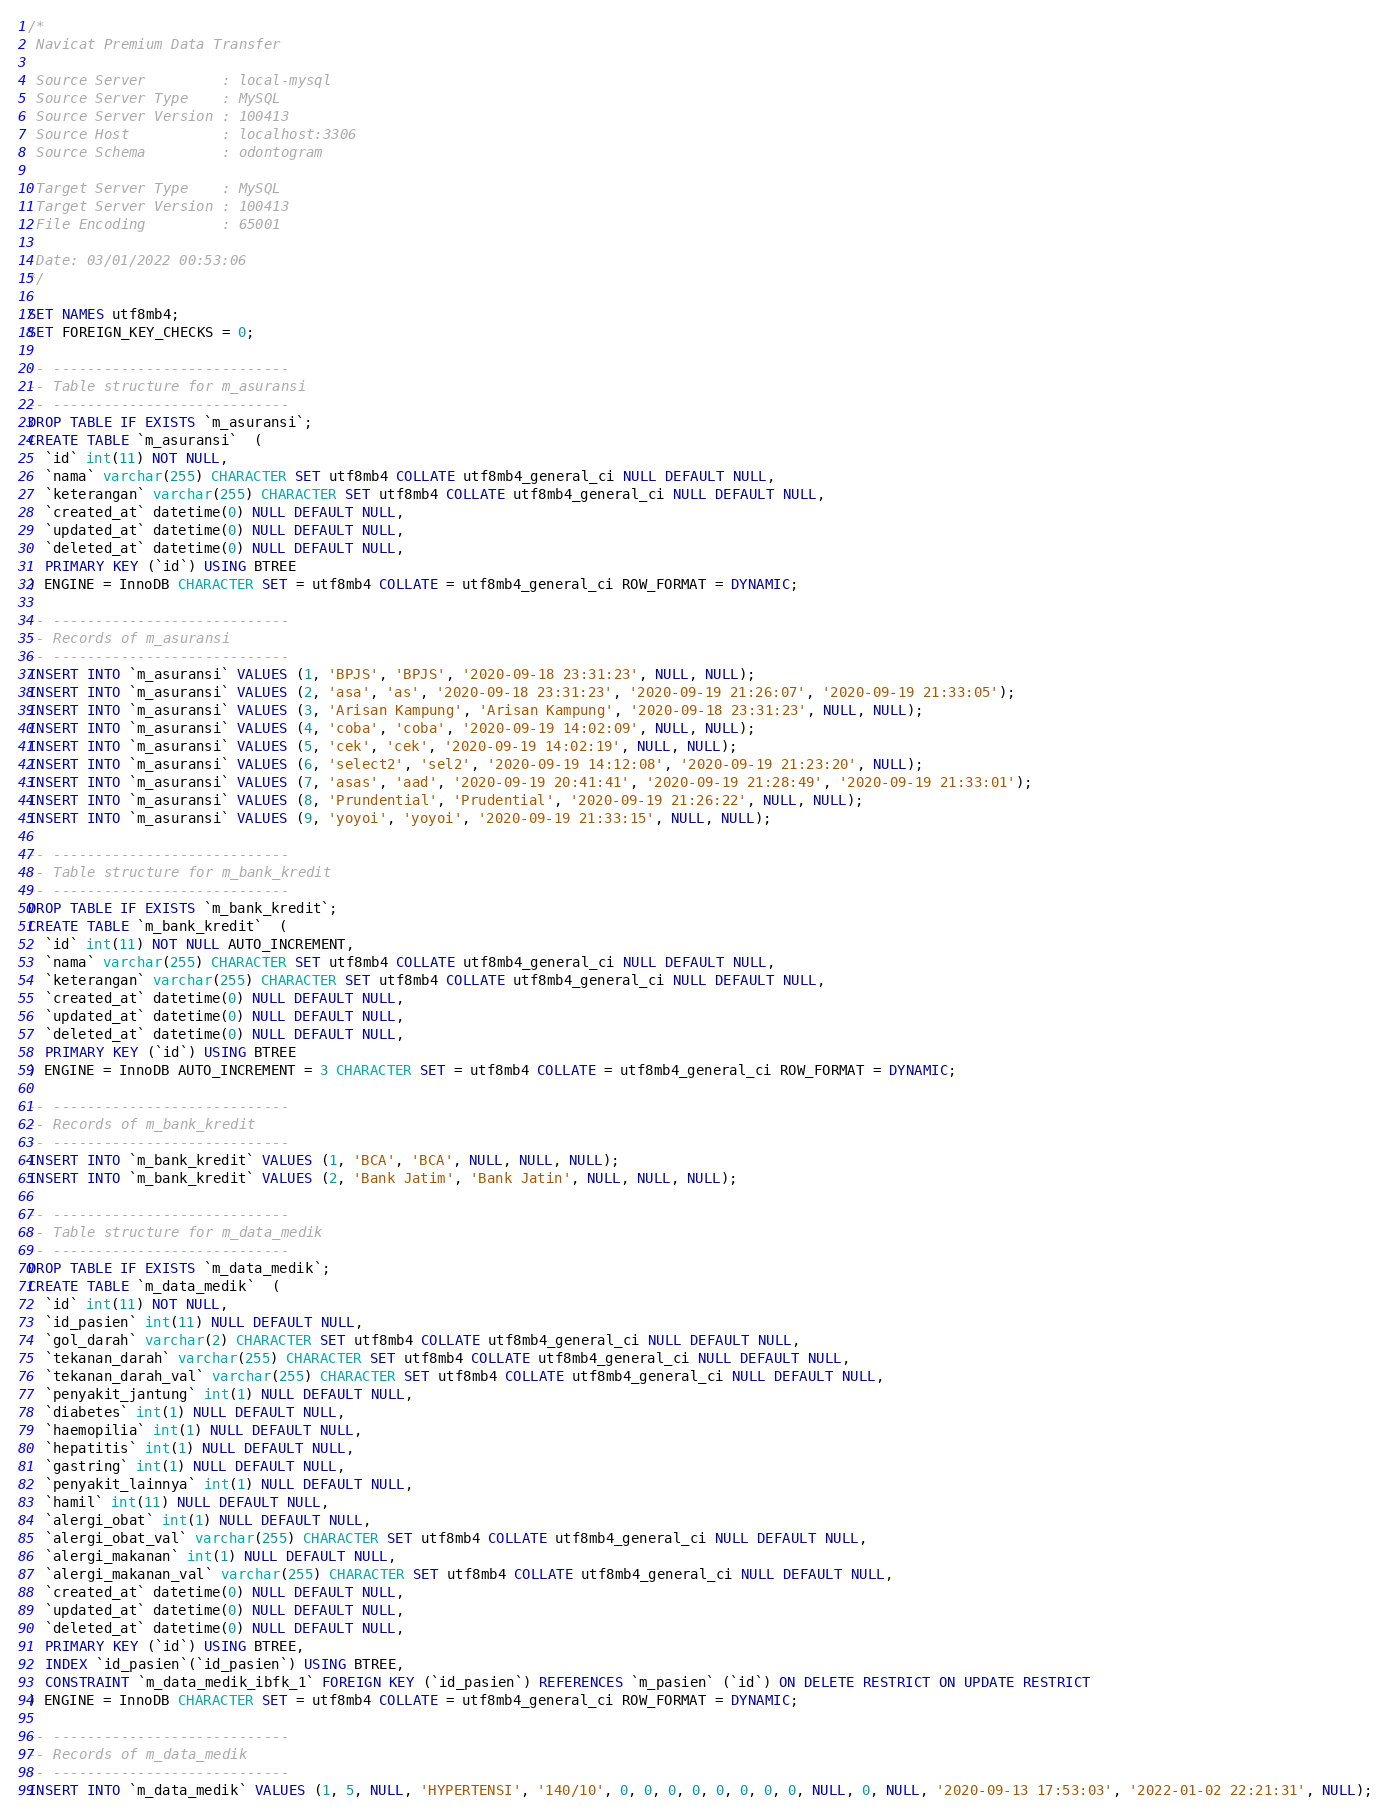Convert code to text. <code><loc_0><loc_0><loc_500><loc_500><_SQL_>/*
 Navicat Premium Data Transfer

 Source Server         : local-mysql
 Source Server Type    : MySQL
 Source Server Version : 100413
 Source Host           : localhost:3306
 Source Schema         : odontogram

 Target Server Type    : MySQL
 Target Server Version : 100413
 File Encoding         : 65001

 Date: 03/01/2022 00:53:06
*/

SET NAMES utf8mb4;
SET FOREIGN_KEY_CHECKS = 0;

-- ----------------------------
-- Table structure for m_asuransi
-- ----------------------------
DROP TABLE IF EXISTS `m_asuransi`;
CREATE TABLE `m_asuransi`  (
  `id` int(11) NOT NULL,
  `nama` varchar(255) CHARACTER SET utf8mb4 COLLATE utf8mb4_general_ci NULL DEFAULT NULL,
  `keterangan` varchar(255) CHARACTER SET utf8mb4 COLLATE utf8mb4_general_ci NULL DEFAULT NULL,
  `created_at` datetime(0) NULL DEFAULT NULL,
  `updated_at` datetime(0) NULL DEFAULT NULL,
  `deleted_at` datetime(0) NULL DEFAULT NULL,
  PRIMARY KEY (`id`) USING BTREE
) ENGINE = InnoDB CHARACTER SET = utf8mb4 COLLATE = utf8mb4_general_ci ROW_FORMAT = DYNAMIC;

-- ----------------------------
-- Records of m_asuransi
-- ----------------------------
INSERT INTO `m_asuransi` VALUES (1, 'BPJS', 'BPJS', '2020-09-18 23:31:23', NULL, NULL);
INSERT INTO `m_asuransi` VALUES (2, 'asa', 'as', '2020-09-18 23:31:23', '2020-09-19 21:26:07', '2020-09-19 21:33:05');
INSERT INTO `m_asuransi` VALUES (3, 'Arisan Kampung', 'Arisan Kampung', '2020-09-18 23:31:23', NULL, NULL);
INSERT INTO `m_asuransi` VALUES (4, 'coba', 'coba', '2020-09-19 14:02:09', NULL, NULL);
INSERT INTO `m_asuransi` VALUES (5, 'cek', 'cek', '2020-09-19 14:02:19', NULL, NULL);
INSERT INTO `m_asuransi` VALUES (6, 'select2', 'sel2', '2020-09-19 14:12:08', '2020-09-19 21:23:20', NULL);
INSERT INTO `m_asuransi` VALUES (7, 'asas', 'aad', '2020-09-19 20:41:41', '2020-09-19 21:28:49', '2020-09-19 21:33:01');
INSERT INTO `m_asuransi` VALUES (8, 'Prundential', 'Prudential', '2020-09-19 21:26:22', NULL, NULL);
INSERT INTO `m_asuransi` VALUES (9, 'yoyoi', 'yoyoi', '2020-09-19 21:33:15', NULL, NULL);

-- ----------------------------
-- Table structure for m_bank_kredit
-- ----------------------------
DROP TABLE IF EXISTS `m_bank_kredit`;
CREATE TABLE `m_bank_kredit`  (
  `id` int(11) NOT NULL AUTO_INCREMENT,
  `nama` varchar(255) CHARACTER SET utf8mb4 COLLATE utf8mb4_general_ci NULL DEFAULT NULL,
  `keterangan` varchar(255) CHARACTER SET utf8mb4 COLLATE utf8mb4_general_ci NULL DEFAULT NULL,
  `created_at` datetime(0) NULL DEFAULT NULL,
  `updated_at` datetime(0) NULL DEFAULT NULL,
  `deleted_at` datetime(0) NULL DEFAULT NULL,
  PRIMARY KEY (`id`) USING BTREE
) ENGINE = InnoDB AUTO_INCREMENT = 3 CHARACTER SET = utf8mb4 COLLATE = utf8mb4_general_ci ROW_FORMAT = DYNAMIC;

-- ----------------------------
-- Records of m_bank_kredit
-- ----------------------------
INSERT INTO `m_bank_kredit` VALUES (1, 'BCA', 'BCA', NULL, NULL, NULL);
INSERT INTO `m_bank_kredit` VALUES (2, 'Bank Jatim', 'Bank Jatin', NULL, NULL, NULL);

-- ----------------------------
-- Table structure for m_data_medik
-- ----------------------------
DROP TABLE IF EXISTS `m_data_medik`;
CREATE TABLE `m_data_medik`  (
  `id` int(11) NOT NULL,
  `id_pasien` int(11) NULL DEFAULT NULL,
  `gol_darah` varchar(2) CHARACTER SET utf8mb4 COLLATE utf8mb4_general_ci NULL DEFAULT NULL,
  `tekanan_darah` varchar(255) CHARACTER SET utf8mb4 COLLATE utf8mb4_general_ci NULL DEFAULT NULL,
  `tekanan_darah_val` varchar(255) CHARACTER SET utf8mb4 COLLATE utf8mb4_general_ci NULL DEFAULT NULL,
  `penyakit_jantung` int(1) NULL DEFAULT NULL,
  `diabetes` int(1) NULL DEFAULT NULL,
  `haemopilia` int(1) NULL DEFAULT NULL,
  `hepatitis` int(1) NULL DEFAULT NULL,
  `gastring` int(1) NULL DEFAULT NULL,
  `penyakit_lainnya` int(1) NULL DEFAULT NULL,
  `hamil` int(11) NULL DEFAULT NULL,
  `alergi_obat` int(1) NULL DEFAULT NULL,
  `alergi_obat_val` varchar(255) CHARACTER SET utf8mb4 COLLATE utf8mb4_general_ci NULL DEFAULT NULL,
  `alergi_makanan` int(1) NULL DEFAULT NULL,
  `alergi_makanan_val` varchar(255) CHARACTER SET utf8mb4 COLLATE utf8mb4_general_ci NULL DEFAULT NULL,
  `created_at` datetime(0) NULL DEFAULT NULL,
  `updated_at` datetime(0) NULL DEFAULT NULL,
  `deleted_at` datetime(0) NULL DEFAULT NULL,
  PRIMARY KEY (`id`) USING BTREE,
  INDEX `id_pasien`(`id_pasien`) USING BTREE,
  CONSTRAINT `m_data_medik_ibfk_1` FOREIGN KEY (`id_pasien`) REFERENCES `m_pasien` (`id`) ON DELETE RESTRICT ON UPDATE RESTRICT
) ENGINE = InnoDB CHARACTER SET = utf8mb4 COLLATE = utf8mb4_general_ci ROW_FORMAT = DYNAMIC;

-- ----------------------------
-- Records of m_data_medik
-- ----------------------------
INSERT INTO `m_data_medik` VALUES (1, 5, NULL, 'HYPERTENSI', '140/10', 0, 0, 0, 0, 0, 0, 0, 0, NULL, 0, NULL, '2020-09-13 17:53:03', '2022-01-02 22:21:31', NULL);</code> 